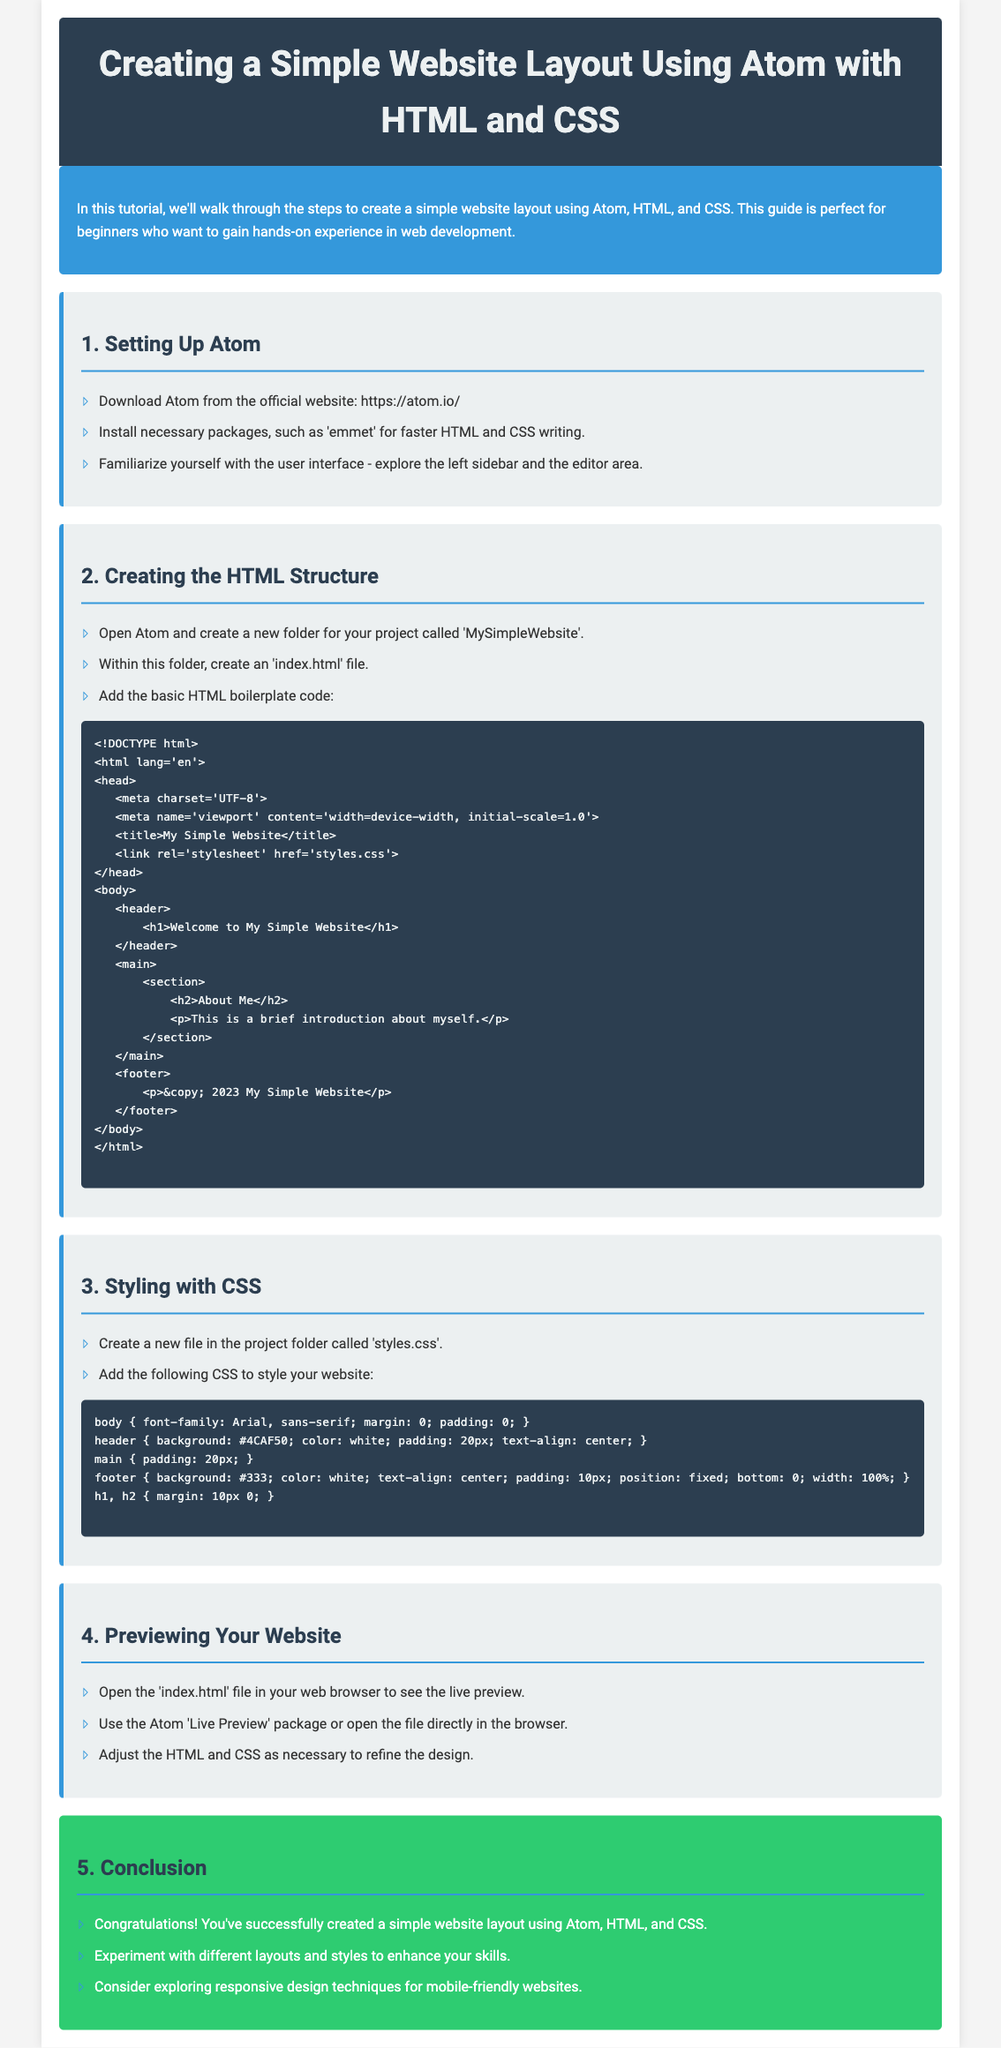what is the title of the tutorial? The title of the tutorial is specified in the document as the main header.
Answer: Creating a Simple Website Layout Using Atom with HTML and CSS what is the main theme of the tutorial? The document provides an introduction about creating a simple website layout using specific tools and languages.
Answer: Simple website layout how many sections are there in the tutorial? The document lists the sections in the body content, which include distinct topics presented in separate parts.
Answer: 5 what is the first step mentioned for setting up Atom? The initial step outlined in the document under the "Setting Up Atom" section describes the first action for the setup.
Answer: Download Atom from the official website what type of file is recommended to create for the HTML structure? The document specifies the type of file needed for building the initial structure of the website.
Answer: index.html what styling file should be created alongside the HTML file? The document clearly states the name of the CSS file that should be created for styling purposes.
Answer: styles.css which package is suggested for faster HTML and CSS writing? The tutorial recommends specific packages to enhance productivity when coding, mentioned under the setup section.
Answer: emmet what color is the header background? The document describes the styling for the header within the CSS section, which includes a specific color for the header background.
Answer: #2c3e50 what content is inside the footnote of the website? The footnote content is explicitly provided in the HTML structure as part of the webpage's overall design.
Answer: © 2023 My Simple Website 